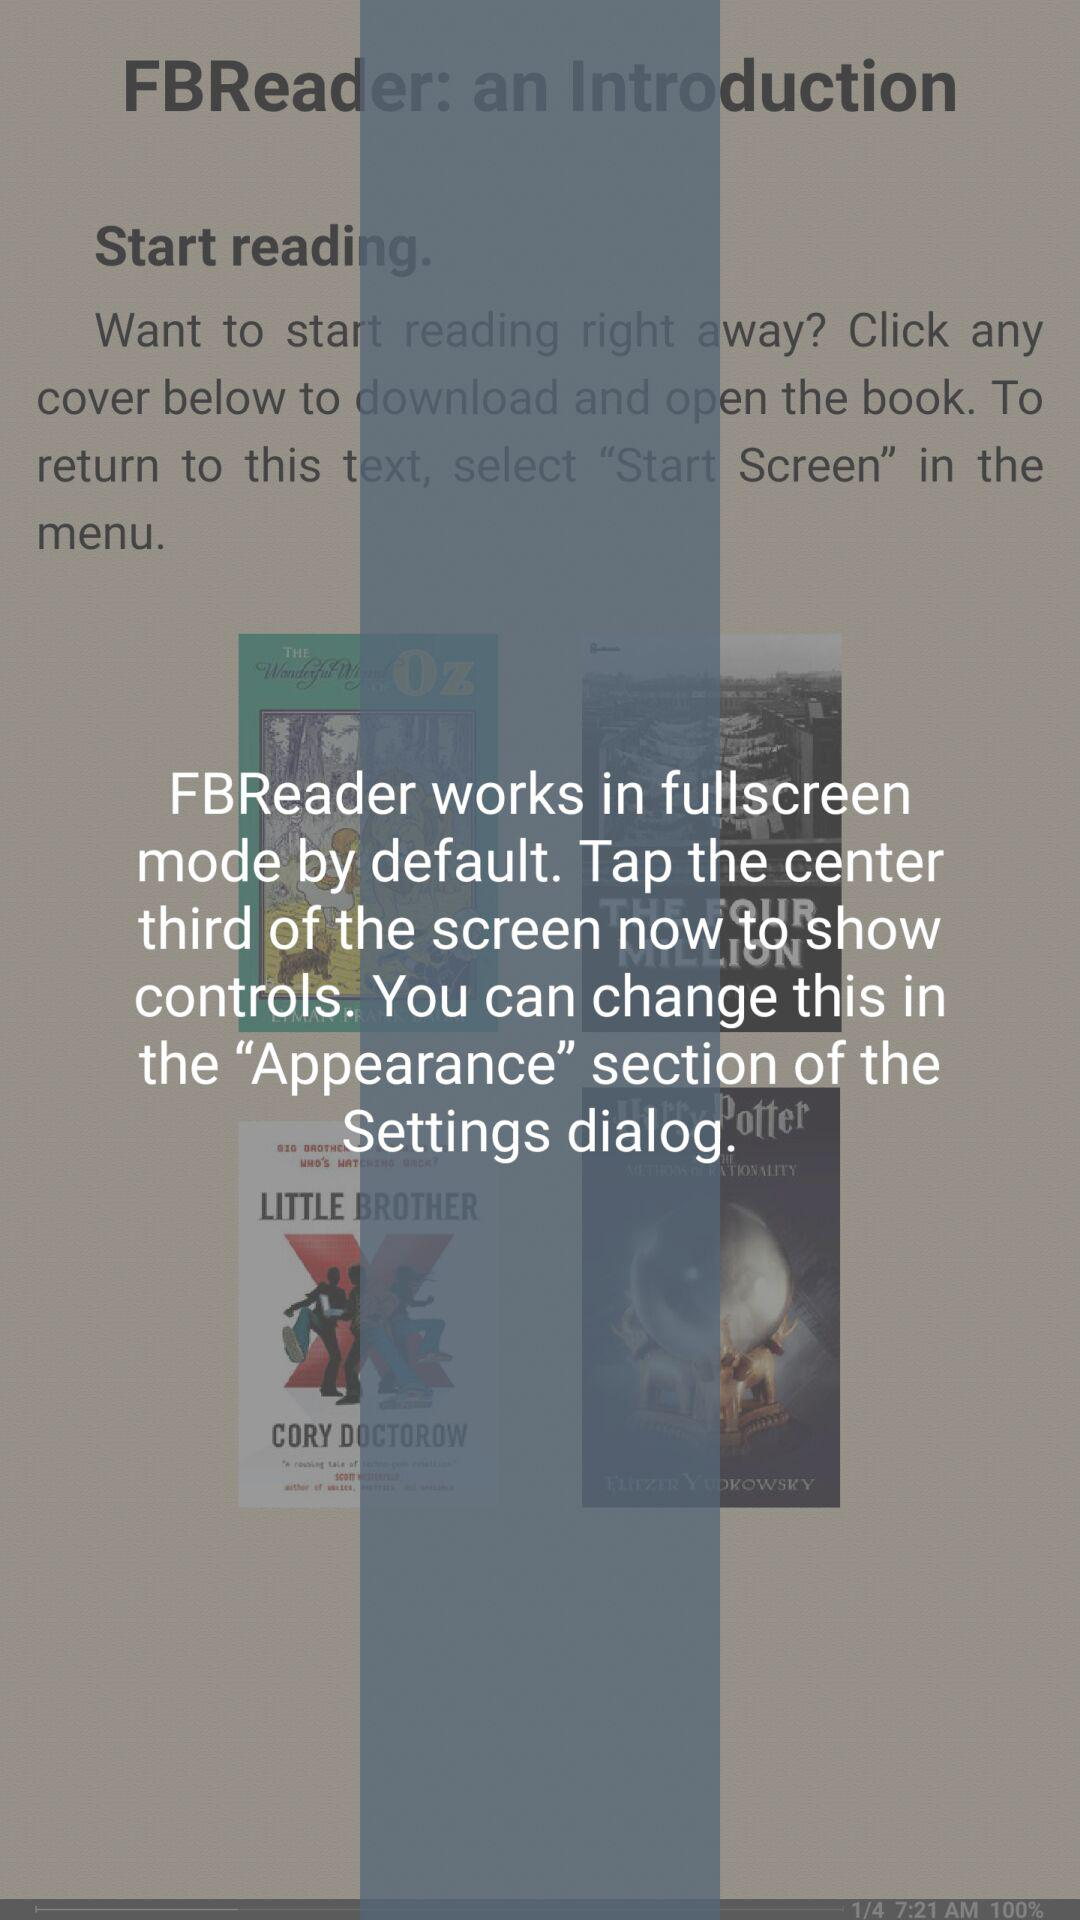What is the application name? The application name is "FBReader". 